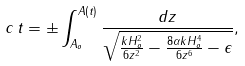<formula> <loc_0><loc_0><loc_500><loc_500>c \, t = \pm \int _ { A _ { o } } ^ { A ( t ) } \frac { d z } { \sqrt { \frac { k H _ { o } ^ { 2 } } { 6 z ^ { 2 } } - \frac { 8 \alpha k H _ { o } ^ { 4 } } { 6 z ^ { 6 } } - \epsilon } } ,</formula> 